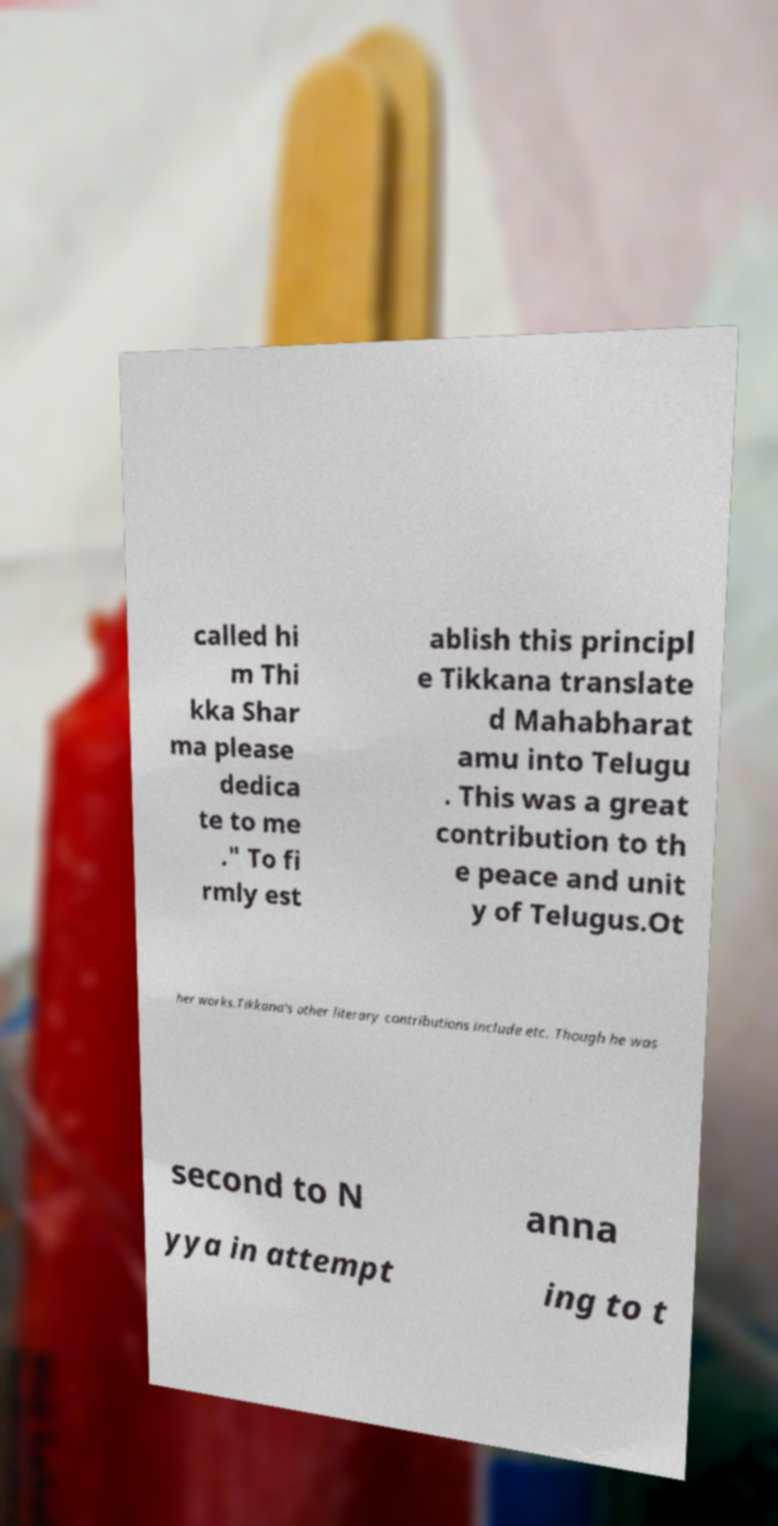Could you assist in decoding the text presented in this image and type it out clearly? called hi m Thi kka Shar ma please dedica te to me ." To fi rmly est ablish this principl e Tikkana translate d Mahabharat amu into Telugu . This was a great contribution to th e peace and unit y of Telugus.Ot her works.Tikkana's other literary contributions include etc. Though he was second to N anna yya in attempt ing to t 